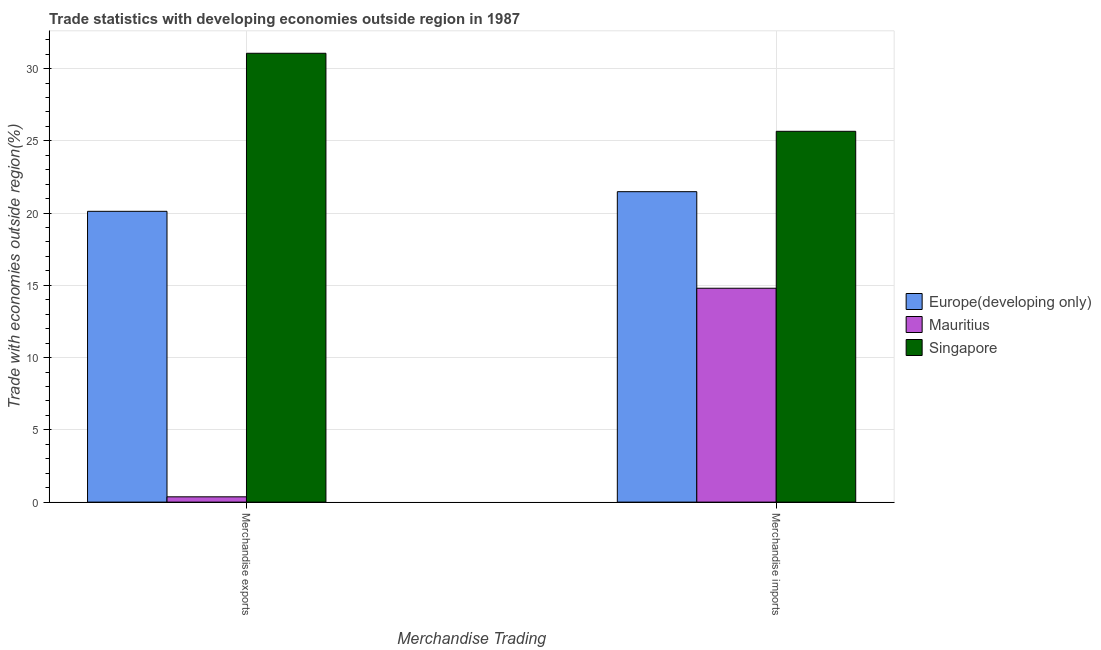How many groups of bars are there?
Ensure brevity in your answer.  2. What is the merchandise exports in Singapore?
Give a very brief answer. 31.06. Across all countries, what is the maximum merchandise exports?
Offer a very short reply. 31.06. Across all countries, what is the minimum merchandise exports?
Offer a very short reply. 0.37. In which country was the merchandise imports maximum?
Offer a terse response. Singapore. In which country was the merchandise imports minimum?
Offer a very short reply. Mauritius. What is the total merchandise imports in the graph?
Provide a succinct answer. 61.94. What is the difference between the merchandise exports in Mauritius and that in Singapore?
Provide a short and direct response. -30.69. What is the difference between the merchandise imports in Singapore and the merchandise exports in Mauritius?
Give a very brief answer. 25.29. What is the average merchandise imports per country?
Offer a very short reply. 20.65. What is the difference between the merchandise imports and merchandise exports in Singapore?
Your answer should be very brief. -5.4. What is the ratio of the merchandise exports in Europe(developing only) to that in Mauritius?
Give a very brief answer. 54.85. In how many countries, is the merchandise imports greater than the average merchandise imports taken over all countries?
Ensure brevity in your answer.  2. What does the 3rd bar from the left in Merchandise exports represents?
Make the answer very short. Singapore. What does the 2nd bar from the right in Merchandise exports represents?
Your answer should be very brief. Mauritius. How many bars are there?
Provide a short and direct response. 6. Are the values on the major ticks of Y-axis written in scientific E-notation?
Your answer should be very brief. No. Does the graph contain any zero values?
Offer a very short reply. No. Does the graph contain grids?
Offer a very short reply. Yes. How are the legend labels stacked?
Offer a very short reply. Vertical. What is the title of the graph?
Provide a succinct answer. Trade statistics with developing economies outside region in 1987. What is the label or title of the X-axis?
Ensure brevity in your answer.  Merchandise Trading. What is the label or title of the Y-axis?
Keep it short and to the point. Trade with economies outside region(%). What is the Trade with economies outside region(%) of Europe(developing only) in Merchandise exports?
Your answer should be very brief. 20.12. What is the Trade with economies outside region(%) of Mauritius in Merchandise exports?
Give a very brief answer. 0.37. What is the Trade with economies outside region(%) in Singapore in Merchandise exports?
Make the answer very short. 31.06. What is the Trade with economies outside region(%) of Europe(developing only) in Merchandise imports?
Provide a succinct answer. 21.48. What is the Trade with economies outside region(%) in Mauritius in Merchandise imports?
Keep it short and to the point. 14.8. What is the Trade with economies outside region(%) in Singapore in Merchandise imports?
Your answer should be compact. 25.66. Across all Merchandise Trading, what is the maximum Trade with economies outside region(%) in Europe(developing only)?
Offer a terse response. 21.48. Across all Merchandise Trading, what is the maximum Trade with economies outside region(%) in Mauritius?
Offer a very short reply. 14.8. Across all Merchandise Trading, what is the maximum Trade with economies outside region(%) in Singapore?
Provide a succinct answer. 31.06. Across all Merchandise Trading, what is the minimum Trade with economies outside region(%) in Europe(developing only)?
Ensure brevity in your answer.  20.12. Across all Merchandise Trading, what is the minimum Trade with economies outside region(%) in Mauritius?
Give a very brief answer. 0.37. Across all Merchandise Trading, what is the minimum Trade with economies outside region(%) of Singapore?
Offer a very short reply. 25.66. What is the total Trade with economies outside region(%) of Europe(developing only) in the graph?
Your response must be concise. 41.61. What is the total Trade with economies outside region(%) of Mauritius in the graph?
Your response must be concise. 15.17. What is the total Trade with economies outside region(%) of Singapore in the graph?
Offer a terse response. 56.72. What is the difference between the Trade with economies outside region(%) in Europe(developing only) in Merchandise exports and that in Merchandise imports?
Provide a short and direct response. -1.36. What is the difference between the Trade with economies outside region(%) of Mauritius in Merchandise exports and that in Merchandise imports?
Provide a succinct answer. -14.43. What is the difference between the Trade with economies outside region(%) of Singapore in Merchandise exports and that in Merchandise imports?
Ensure brevity in your answer.  5.4. What is the difference between the Trade with economies outside region(%) in Europe(developing only) in Merchandise exports and the Trade with economies outside region(%) in Mauritius in Merchandise imports?
Your answer should be compact. 5.32. What is the difference between the Trade with economies outside region(%) in Europe(developing only) in Merchandise exports and the Trade with economies outside region(%) in Singapore in Merchandise imports?
Your answer should be compact. -5.54. What is the difference between the Trade with economies outside region(%) of Mauritius in Merchandise exports and the Trade with economies outside region(%) of Singapore in Merchandise imports?
Make the answer very short. -25.29. What is the average Trade with economies outside region(%) in Europe(developing only) per Merchandise Trading?
Offer a very short reply. 20.8. What is the average Trade with economies outside region(%) in Mauritius per Merchandise Trading?
Keep it short and to the point. 7.58. What is the average Trade with economies outside region(%) of Singapore per Merchandise Trading?
Ensure brevity in your answer.  28.36. What is the difference between the Trade with economies outside region(%) in Europe(developing only) and Trade with economies outside region(%) in Mauritius in Merchandise exports?
Keep it short and to the point. 19.76. What is the difference between the Trade with economies outside region(%) of Europe(developing only) and Trade with economies outside region(%) of Singapore in Merchandise exports?
Make the answer very short. -10.94. What is the difference between the Trade with economies outside region(%) of Mauritius and Trade with economies outside region(%) of Singapore in Merchandise exports?
Your answer should be compact. -30.69. What is the difference between the Trade with economies outside region(%) in Europe(developing only) and Trade with economies outside region(%) in Mauritius in Merchandise imports?
Ensure brevity in your answer.  6.68. What is the difference between the Trade with economies outside region(%) in Europe(developing only) and Trade with economies outside region(%) in Singapore in Merchandise imports?
Provide a short and direct response. -4.18. What is the difference between the Trade with economies outside region(%) in Mauritius and Trade with economies outside region(%) in Singapore in Merchandise imports?
Your answer should be compact. -10.86. What is the ratio of the Trade with economies outside region(%) in Europe(developing only) in Merchandise exports to that in Merchandise imports?
Offer a very short reply. 0.94. What is the ratio of the Trade with economies outside region(%) in Mauritius in Merchandise exports to that in Merchandise imports?
Provide a short and direct response. 0.02. What is the ratio of the Trade with economies outside region(%) in Singapore in Merchandise exports to that in Merchandise imports?
Make the answer very short. 1.21. What is the difference between the highest and the second highest Trade with economies outside region(%) in Europe(developing only)?
Provide a succinct answer. 1.36. What is the difference between the highest and the second highest Trade with economies outside region(%) of Mauritius?
Your answer should be very brief. 14.43. What is the difference between the highest and the second highest Trade with economies outside region(%) of Singapore?
Offer a very short reply. 5.4. What is the difference between the highest and the lowest Trade with economies outside region(%) of Europe(developing only)?
Give a very brief answer. 1.36. What is the difference between the highest and the lowest Trade with economies outside region(%) of Mauritius?
Your response must be concise. 14.43. What is the difference between the highest and the lowest Trade with economies outside region(%) in Singapore?
Ensure brevity in your answer.  5.4. 